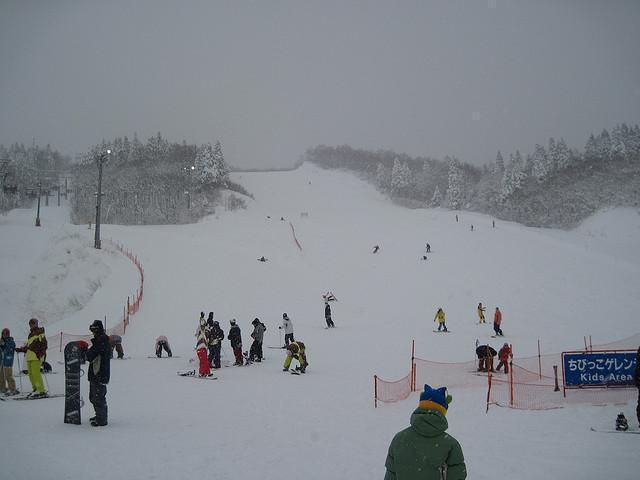Why is this hill so small?
Choose the correct response, then elucidate: 'Answer: answer
Rationale: rationale.'
Options: For practice, buried snow, nothing else, for children. Answer: for children.
Rationale: The hill is set up for beginner skiers and often that is how children learn. 